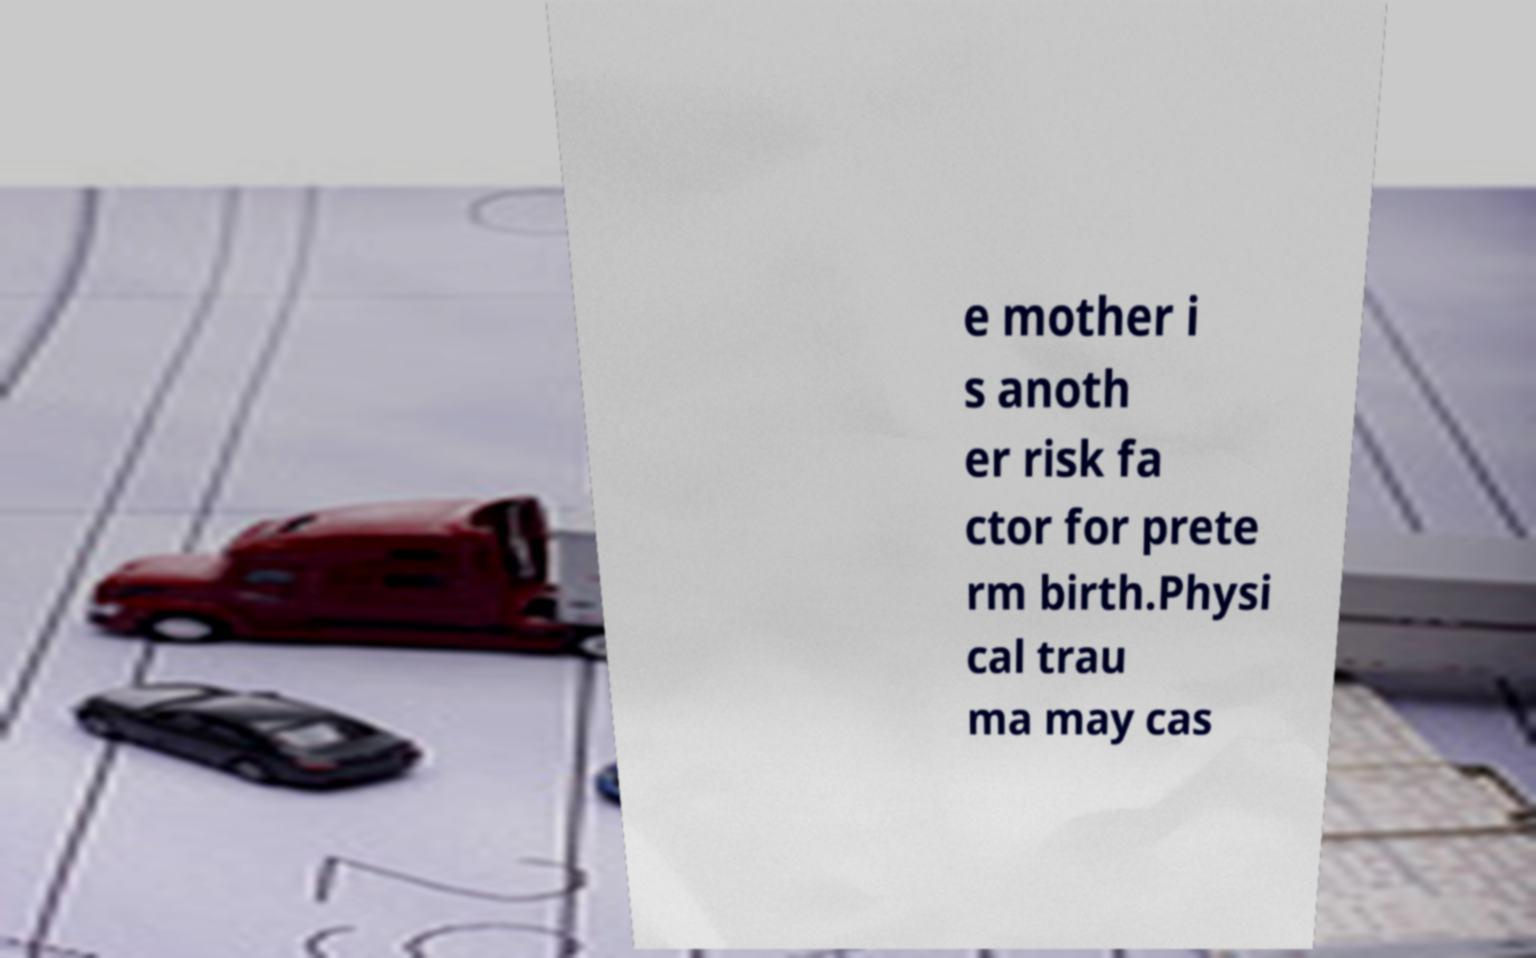Can you read and provide the text displayed in the image?This photo seems to have some interesting text. Can you extract and type it out for me? e mother i s anoth er risk fa ctor for prete rm birth.Physi cal trau ma may cas 